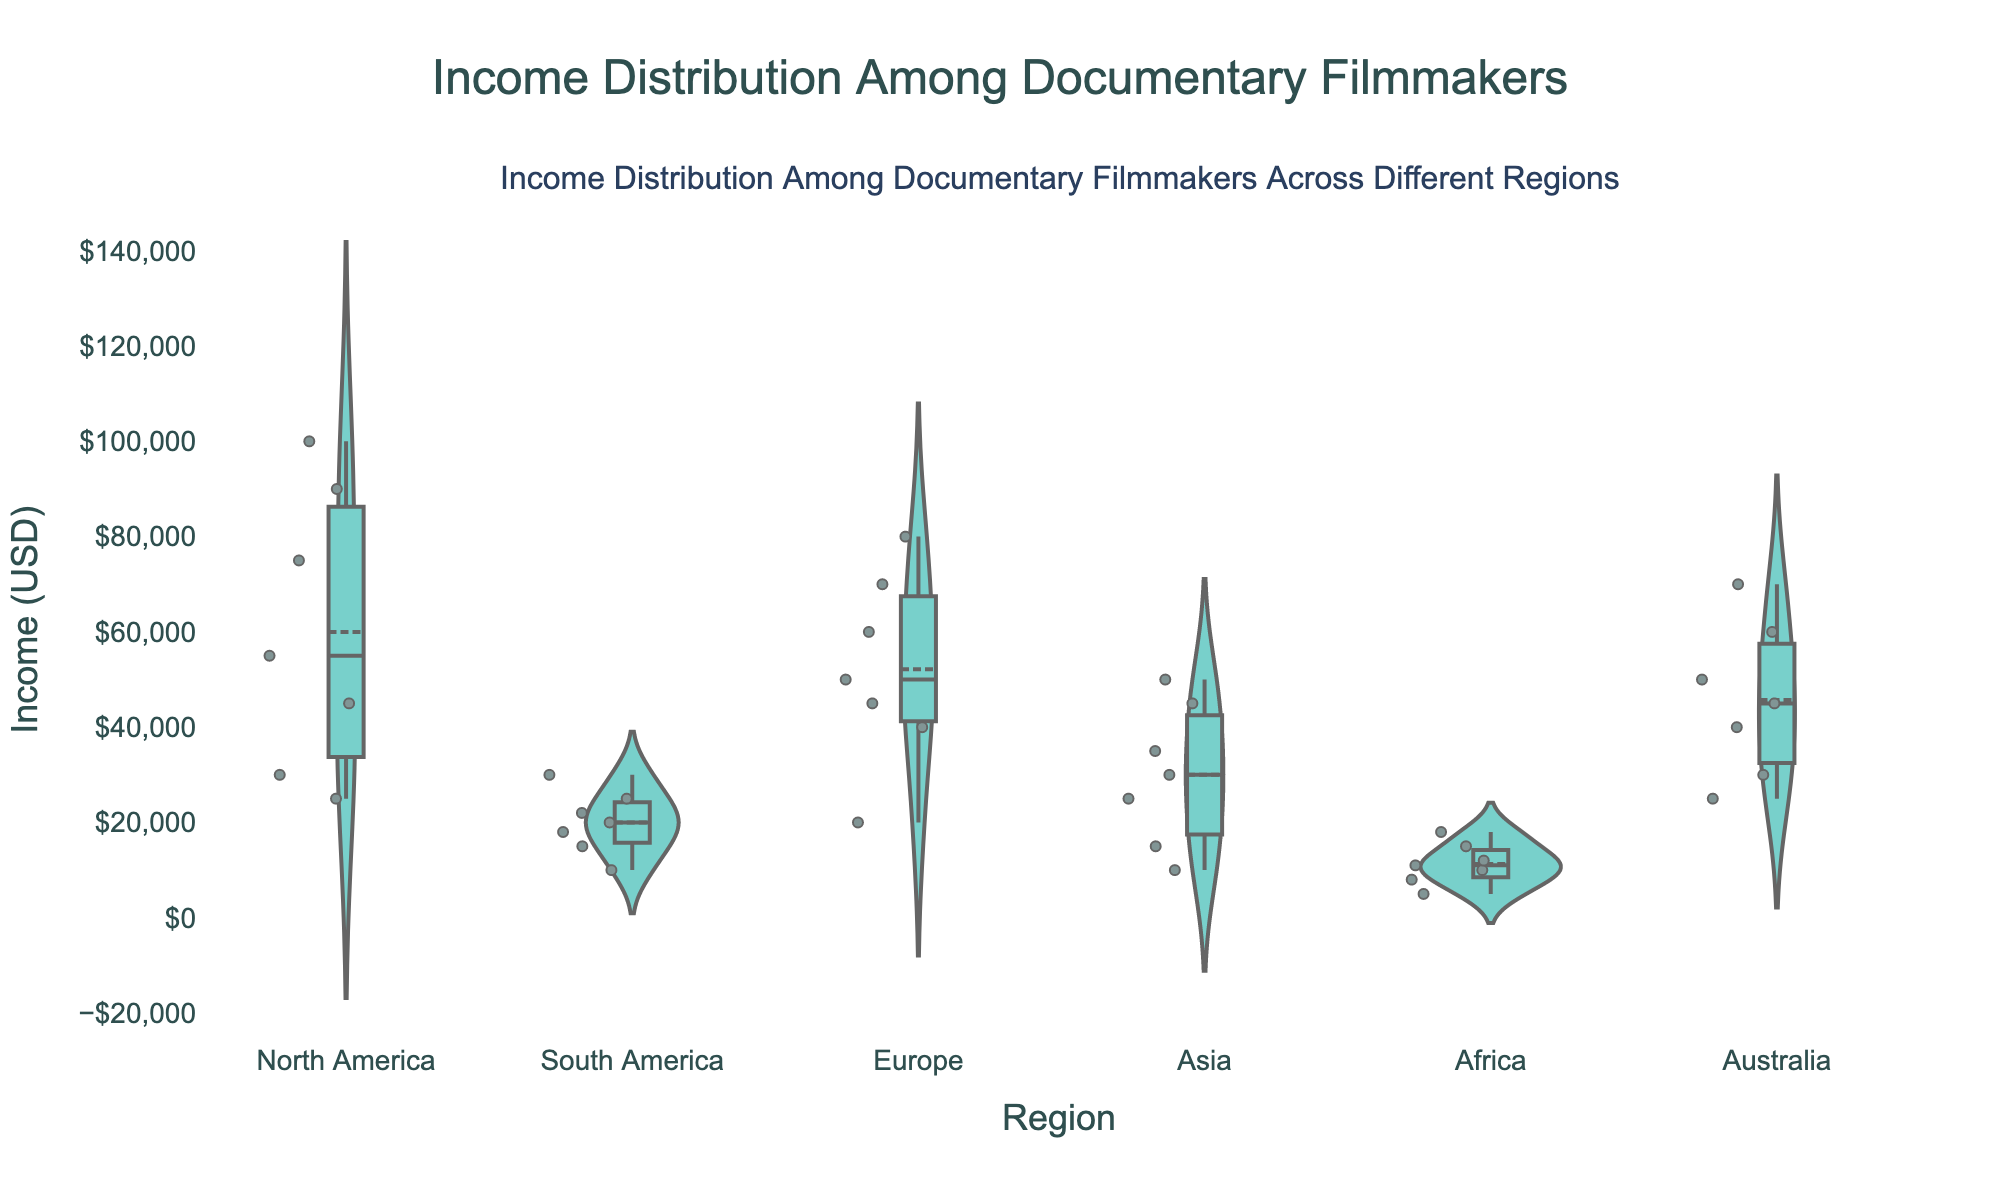what is the title of the plot? The title of the plot is usually placed at the top center and is in a larger font compared to other text elements.
Answer: Income Distribution Among Documentary Filmmakers Which region shows the lowest median income? The median value in a violin plot is typically indicated by a line in the middle of the distribution. The lowest median line can be visually compared across different regions.
Answer: Africa Which region has the widest range of incomes? The range of incomes can be determined by looking at the spread of data points from the minimum to the maximum within each violin plot. The widest spread indicates the largest range.
Answer: North America What is the mean income for documentary filmmakers in Europe? In a violin plot, the mean can be identified by the mean line visible within the distribution. In Europe, the mean line indicates the central point of the distribution.
Answer: Approximately $51,429 Which region has data points showing the highest income for documentary filmmakers? The highest data points can be recognized at the top of the violin plots. Compare the maximum values across all regions.
Answer: North America How does the interquartile range (IQR) of incomes in South America compare to that in Asia? The IQR can be visualized by the box within the violin plot. It represents the middle 50% of the data. Compare the IQRs of the two specified regions to see which has a broader or narrower middle range.
Answer: South America has a narrower IQR than Asia Which region shows the most uniform income distribution? A uniform distribution would show a more evenly spread density with fewer peaks and troughs. Visually inspect each region's plot for the flattest distribution.
Answer: South America Does the income distribution in North America appear to be skewed? If so, in which direction? In a violin plot, skewness can be observed by the shape and spread of the distribution. If there is a longer tail on one side, it indicates skewness.
Answer: Yes, positively skewed What is the approximate income range for documentary filmmakers in Australia? The income range can be estimated by identifying the minimum and maximum points within the violin plot for Australia.
Answer: $25,000 to $70,000 